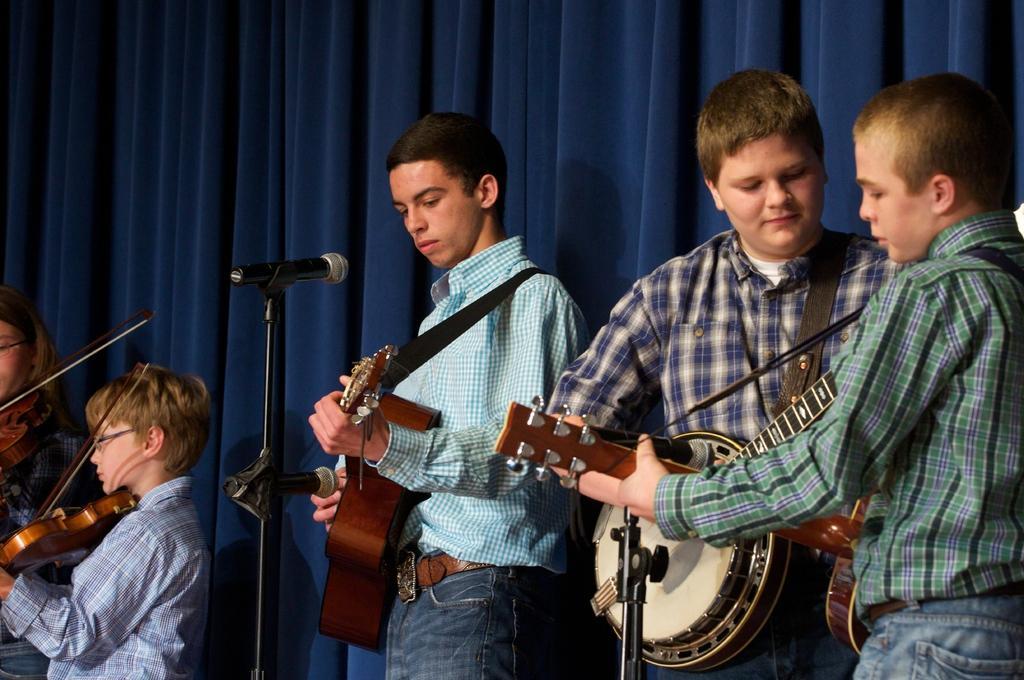Describe this image in one or two sentences. In this image I see 5 persons and all of them are holding musical instruments and there is a mic over here. In the background I see a curtain which is of blue in color. 